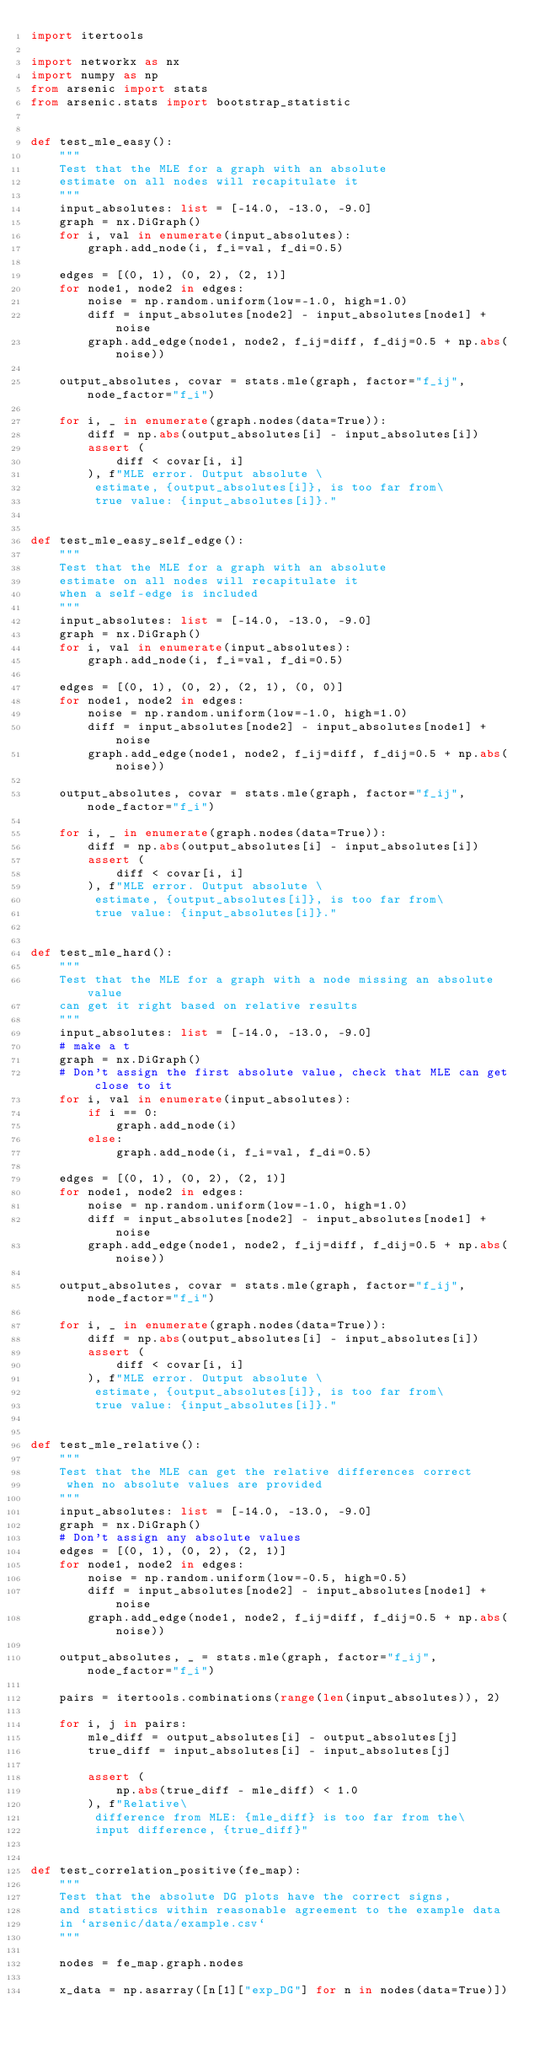Convert code to text. <code><loc_0><loc_0><loc_500><loc_500><_Python_>import itertools

import networkx as nx
import numpy as np
from arsenic import stats
from arsenic.stats import bootstrap_statistic


def test_mle_easy():
    """
    Test that the MLE for a graph with an absolute
    estimate on all nodes will recapitulate it
    """
    input_absolutes: list = [-14.0, -13.0, -9.0]
    graph = nx.DiGraph()
    for i, val in enumerate(input_absolutes):
        graph.add_node(i, f_i=val, f_di=0.5)

    edges = [(0, 1), (0, 2), (2, 1)]
    for node1, node2 in edges:
        noise = np.random.uniform(low=-1.0, high=1.0)
        diff = input_absolutes[node2] - input_absolutes[node1] + noise
        graph.add_edge(node1, node2, f_ij=diff, f_dij=0.5 + np.abs(noise))

    output_absolutes, covar = stats.mle(graph, factor="f_ij", node_factor="f_i")

    for i, _ in enumerate(graph.nodes(data=True)):
        diff = np.abs(output_absolutes[i] - input_absolutes[i])
        assert (
            diff < covar[i, i]
        ), f"MLE error. Output absolute \
         estimate, {output_absolutes[i]}, is too far from\
         true value: {input_absolutes[i]}."


def test_mle_easy_self_edge():
    """
    Test that the MLE for a graph with an absolute
    estimate on all nodes will recapitulate it
    when a self-edge is included
    """
    input_absolutes: list = [-14.0, -13.0, -9.0]
    graph = nx.DiGraph()
    for i, val in enumerate(input_absolutes):
        graph.add_node(i, f_i=val, f_di=0.5)

    edges = [(0, 1), (0, 2), (2, 1), (0, 0)]
    for node1, node2 in edges:
        noise = np.random.uniform(low=-1.0, high=1.0)
        diff = input_absolutes[node2] - input_absolutes[node1] + noise
        graph.add_edge(node1, node2, f_ij=diff, f_dij=0.5 + np.abs(noise))

    output_absolutes, covar = stats.mle(graph, factor="f_ij", node_factor="f_i")

    for i, _ in enumerate(graph.nodes(data=True)):
        diff = np.abs(output_absolutes[i] - input_absolutes[i])
        assert (
            diff < covar[i, i]
        ), f"MLE error. Output absolute \
         estimate, {output_absolutes[i]}, is too far from\
         true value: {input_absolutes[i]}."


def test_mle_hard():
    """
    Test that the MLE for a graph with a node missing an absolute value
    can get it right based on relative results
    """
    input_absolutes: list = [-14.0, -13.0, -9.0]
    # make a t
    graph = nx.DiGraph()
    # Don't assign the first absolute value, check that MLE can get close to it
    for i, val in enumerate(input_absolutes):
        if i == 0:
            graph.add_node(i)
        else:
            graph.add_node(i, f_i=val, f_di=0.5)

    edges = [(0, 1), (0, 2), (2, 1)]
    for node1, node2 in edges:
        noise = np.random.uniform(low=-1.0, high=1.0)
        diff = input_absolutes[node2] - input_absolutes[node1] + noise
        graph.add_edge(node1, node2, f_ij=diff, f_dij=0.5 + np.abs(noise))

    output_absolutes, covar = stats.mle(graph, factor="f_ij", node_factor="f_i")

    for i, _ in enumerate(graph.nodes(data=True)):
        diff = np.abs(output_absolutes[i] - input_absolutes[i])
        assert (
            diff < covar[i, i]
        ), f"MLE error. Output absolute \
         estimate, {output_absolutes[i]}, is too far from\
         true value: {input_absolutes[i]}."


def test_mle_relative():
    """
    Test that the MLE can get the relative differences correct
     when no absolute values are provided
    """
    input_absolutes: list = [-14.0, -13.0, -9.0]
    graph = nx.DiGraph()
    # Don't assign any absolute values
    edges = [(0, 1), (0, 2), (2, 1)]
    for node1, node2 in edges:
        noise = np.random.uniform(low=-0.5, high=0.5)
        diff = input_absolutes[node2] - input_absolutes[node1] + noise
        graph.add_edge(node1, node2, f_ij=diff, f_dij=0.5 + np.abs(noise))

    output_absolutes, _ = stats.mle(graph, factor="f_ij", node_factor="f_i")

    pairs = itertools.combinations(range(len(input_absolutes)), 2)

    for i, j in pairs:
        mle_diff = output_absolutes[i] - output_absolutes[j]
        true_diff = input_absolutes[i] - input_absolutes[j]

        assert (
            np.abs(true_diff - mle_diff) < 1.0
        ), f"Relative\
         difference from MLE: {mle_diff} is too far from the\
         input difference, {true_diff}"


def test_correlation_positive(fe_map):
    """
    Test that the absolute DG plots have the correct signs,
    and statistics within reasonable agreement to the example data
    in `arsenic/data/example.csv`
    """

    nodes = fe_map.graph.nodes

    x_data = np.asarray([n[1]["exp_DG"] for n in nodes(data=True)])</code> 